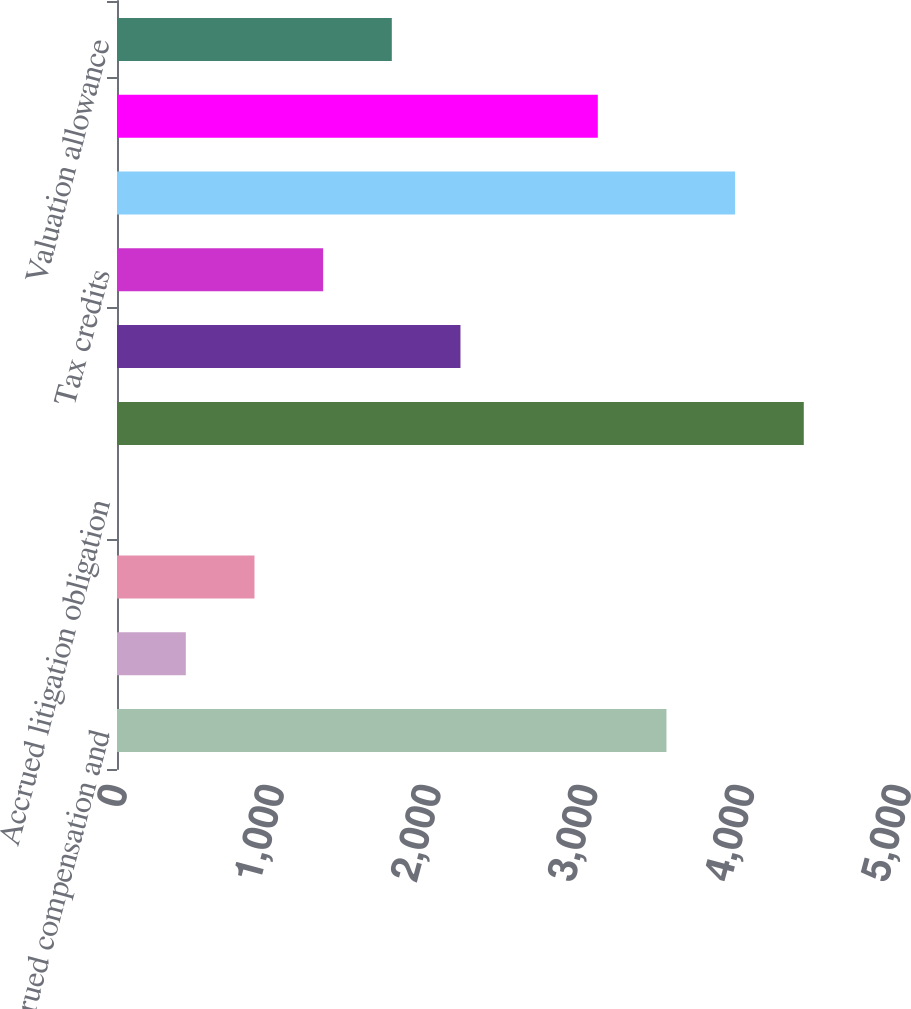<chart> <loc_0><loc_0><loc_500><loc_500><bar_chart><fcel>Accrued compensation and<fcel>Comprehensive (income) loss<fcel>Investments in joint ventures<fcel>Accrued litigation obligation<fcel>Client incentives<fcel>Net operating loss<fcel>Tax credits<fcel>Federal benefit of state taxes<fcel>Other<fcel>Valuation allowance<nl><fcel>3504.2<fcel>438.9<fcel>876.8<fcel>1<fcel>4380<fcel>2190.5<fcel>1314.7<fcel>3942.1<fcel>3066.3<fcel>1752.6<nl></chart> 